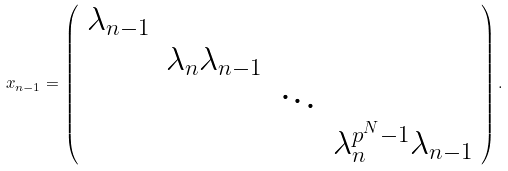<formula> <loc_0><loc_0><loc_500><loc_500>x _ { n - 1 } = \left ( \begin{array} { c c c c } \lambda _ { n - 1 } & & & \\ & \lambda _ { n } \lambda _ { n - 1 } & & \\ & & \ddots & \\ & & & \lambda _ { n } ^ { p ^ { N } - 1 } \lambda _ { n - 1 } \end{array} \right ) .</formula> 